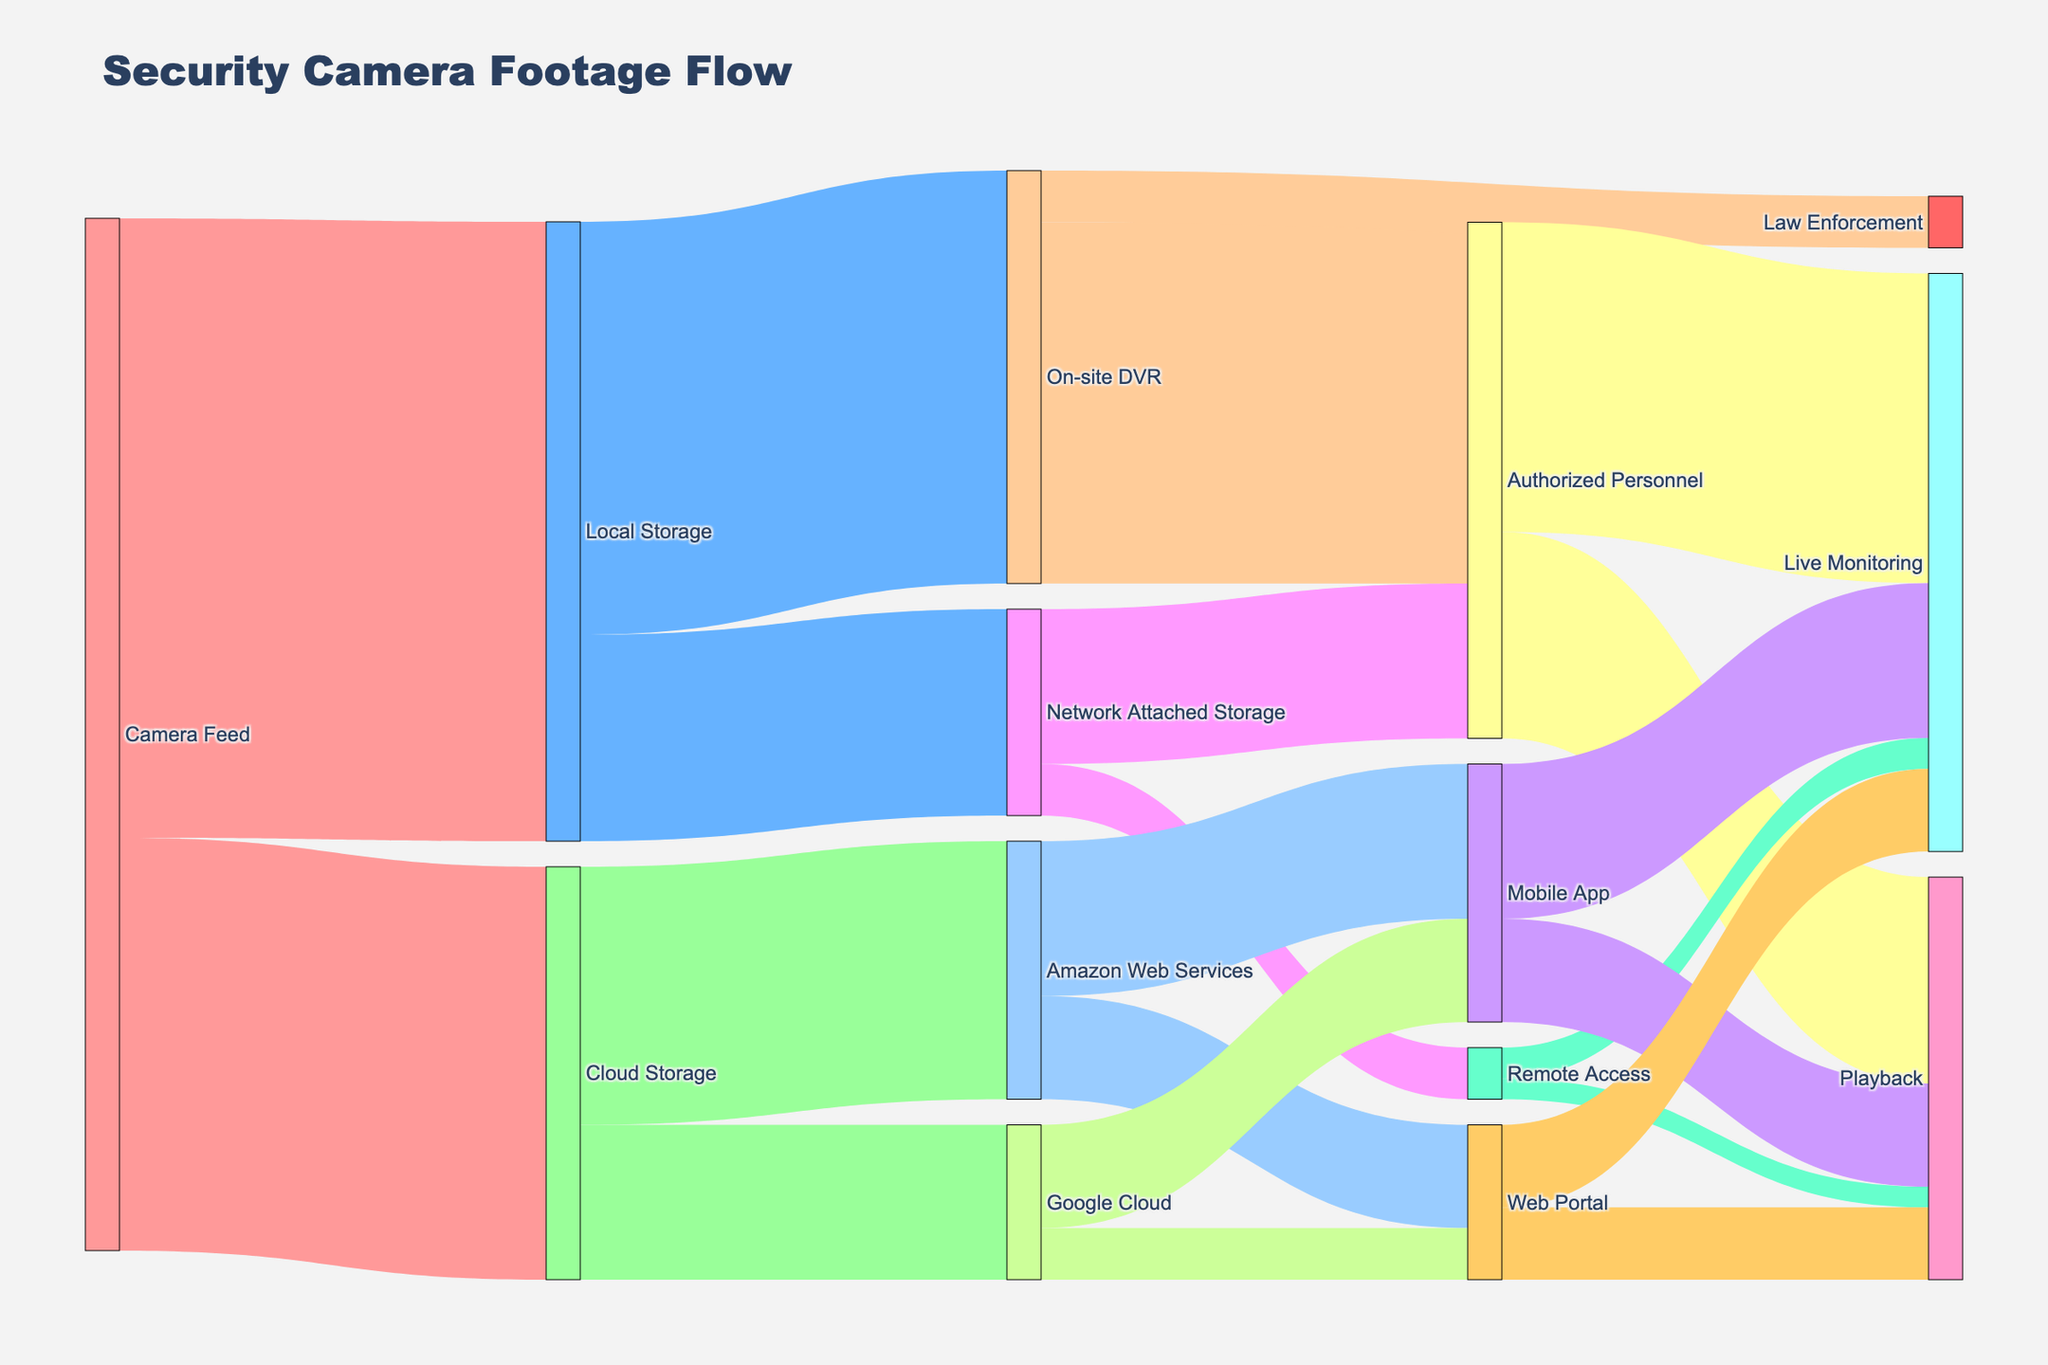What's the title of the figure? The figure's title is located at the top of the diagram, usually written in a larger or bold font to distinguish it from other text. In this case, it reads "Security Camera Footage Flow."
Answer: Security Camera Footage Flow How many cameras use cloud storage for footage? To find the number of cameras using cloud storage, look at the link from "Camera Feed" to "Cloud Storage." The value associated with this link indicates how many cameras use this method. According to the figure, the value is 40.
Answer: 40 Which storage method receives the highest amount of camera feed? To find which method receives the highest amount of camera feed, compare the values of links from "Camera Feed" to "Local Storage" and "Cloud Storage." "Local Storage" has a value of 60, which is higher than "Cloud Storage" at 40.
Answer: Local Storage How many storage methods are linked to "Local Storage"? The figure shows links from "Local Storage" to its connected storage methods. The ones connected are "On-site DVR" and "Network Attached Storage." This totals to 2 storage methods.
Answer: 2 What percentage of the feed stored in the cloud goes to Amazon Web Services? The value of footage to "Cloud Storage" is 40. Out of this, 25 goes to Amazon Web Services. The percentage is then (25/40) * 100.
Answer: 62.5% Who are the main users accessing footage stored on "On-site DVR"? From "On-site DVR," the links go to "Authorized Personnel" and "Law Enforcement." By comparing values, "Authorized Personnel" has 35 and "Law Enforcement" has 5. Thus, the main users are "Authorized Personnel."
Answer: Authorized Personnel Calculate the total footage accessible via Mobile App. Footage to Mobile App comes from both "Amazon Web Services" and "Google Cloud." Add these values: 15 + 10 = 25.
Answer: 25 Compare the amount of live monitoring via Web Portal and Remote Access Check the links from "Web Portal" to "Live Monitoring" (8) and from "Remote Access" to "Live Monitoring" (3). Compare these values; 8 is greater than 3.
Answer: Web Portal Which access method has a higher share for playback: Mobile App or Web Portal? Compare the values from "Mobile App" to "Playback" (10), and "Web Portal" to "Playback" (7). "Mobile App" has a higher share at 10.
Answer: Mobile App 